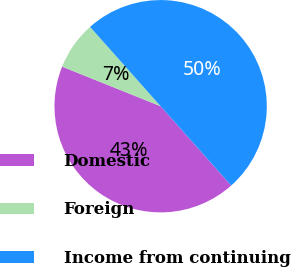<chart> <loc_0><loc_0><loc_500><loc_500><pie_chart><fcel>Domestic<fcel>Foreign<fcel>Income from continuing<nl><fcel>42.65%<fcel>7.35%<fcel>50.0%<nl></chart> 